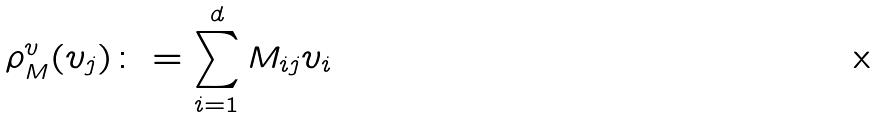<formula> <loc_0><loc_0><loc_500><loc_500>\rho ^ { v } _ { M } ( v _ { j } ) \colon = \sum _ { i = 1 } ^ { d } M _ { i j } v _ { i }</formula> 